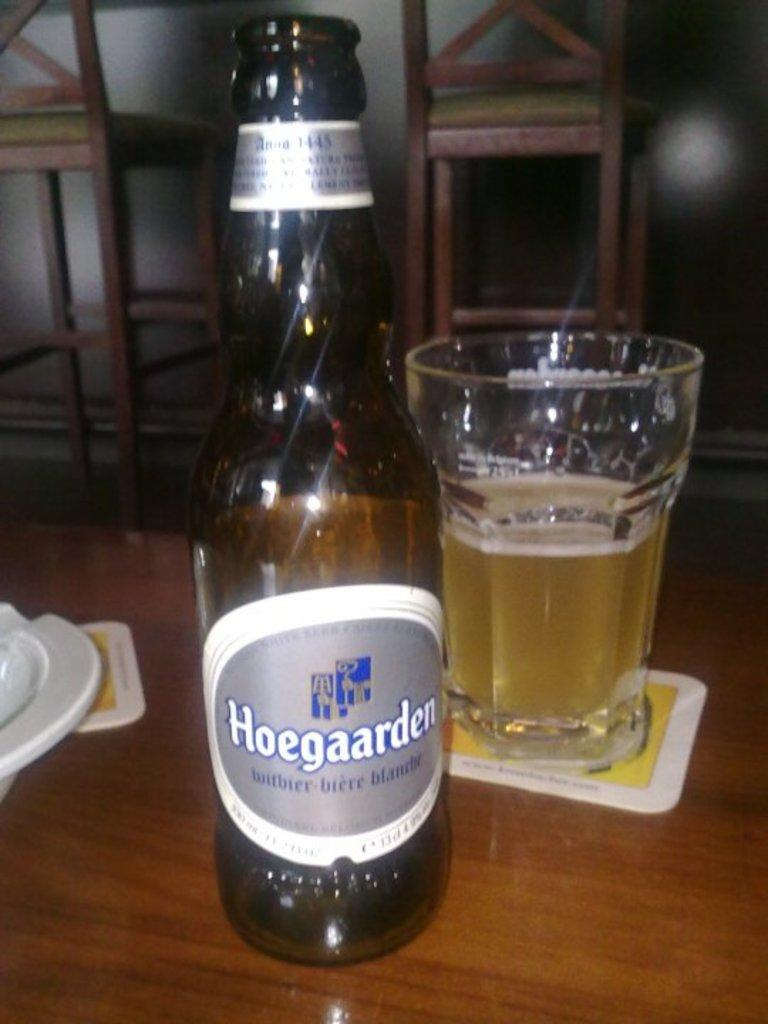<image>
Render a clear and concise summary of the photo. A bottle of Hoegaarden has been poured into a glass on a coaster 